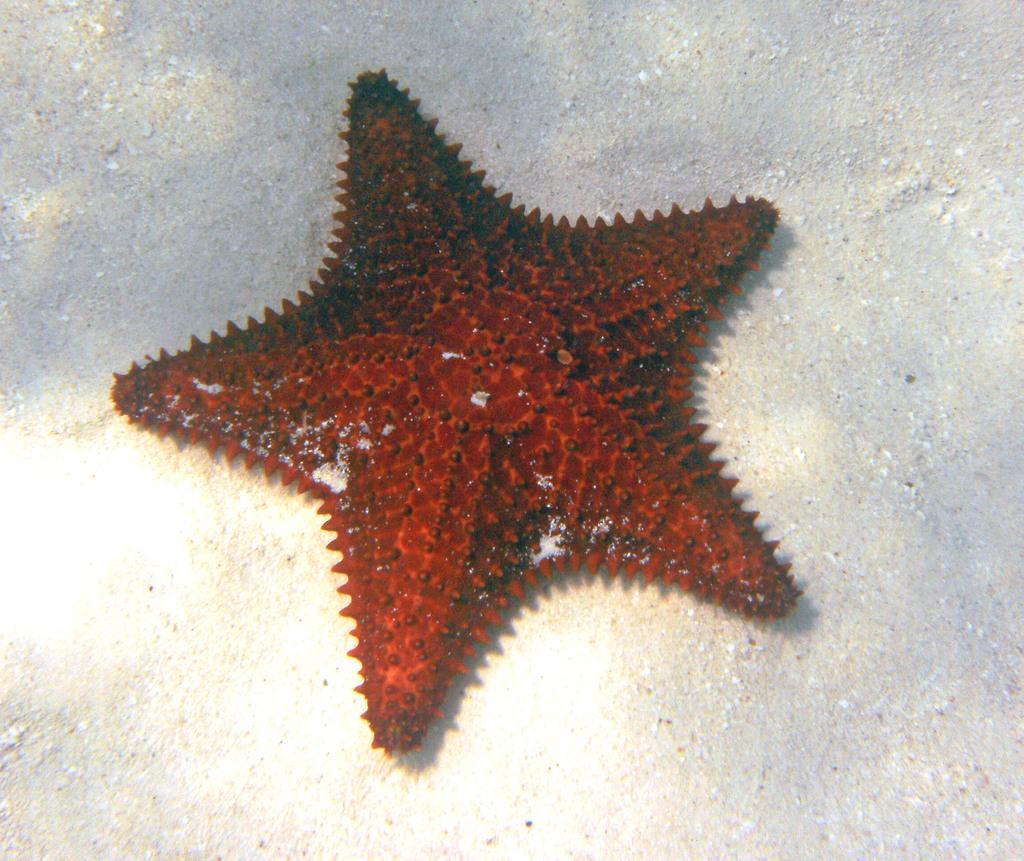Could you give a brief overview of what you see in this image? In this image, we can see a starfish on the surface. 